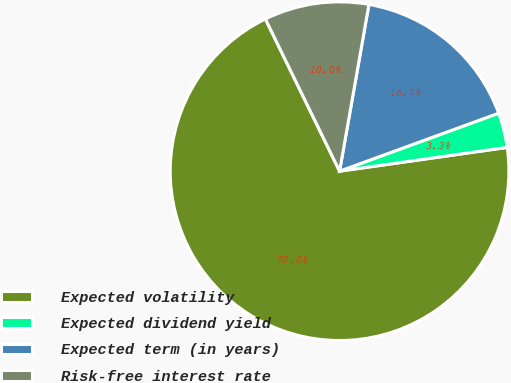Convert chart to OTSL. <chart><loc_0><loc_0><loc_500><loc_500><pie_chart><fcel>Expected volatility<fcel>Expected dividend yield<fcel>Expected term (in years)<fcel>Risk-free interest rate<nl><fcel>70.02%<fcel>3.32%<fcel>16.66%<fcel>9.99%<nl></chart> 